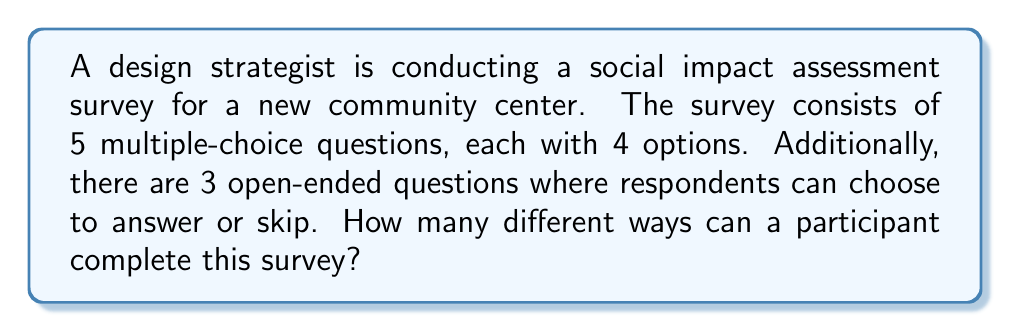Help me with this question. Let's break this down step-by-step:

1. For the multiple-choice questions:
   - There are 5 questions, each with 4 options.
   - For each question, the participant has 4 choices.
   - Using the multiplication principle, we have: $4^5$ possible combinations.

2. For the open-ended questions:
   - There are 3 questions.
   - For each question, the participant can choose to answer or skip.
   - This creates 2 options for each open-ended question.
   - Again, using the multiplication principle, we have: $2^3$ possible combinations.

3. To find the total number of ways to complete the survey:
   - We multiply the number of possibilities for multiple-choice and open-ended sections.
   - Total possibilities = (Multiple-choice possibilities) × (Open-ended possibilities)
   - Total possibilities = $4^5 \times 2^3$

4. Calculating the final result:
   $$ 4^5 \times 2^3 = 1024 \times 8 = 8192 $$

This calculation considers cultural and social implications by allowing for open-ended responses, which can capture diverse perspectives and experiences that might not be captured in multiple-choice questions alone.
Answer: 8192 